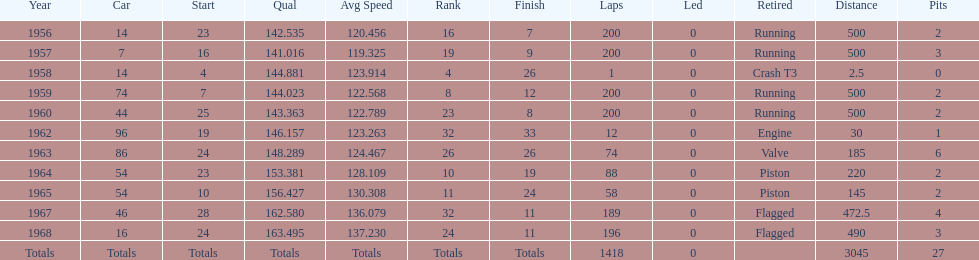Did bob veith drive more indy 500 laps in the 1950s or 1960s? 1960s. 